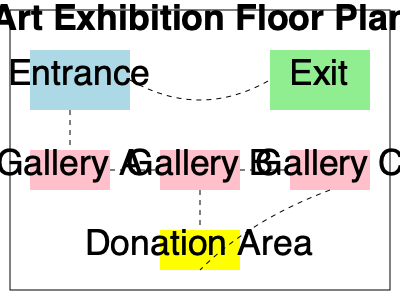Based on the floor plan of the art exhibition, what is the optimal guest flow path to maximize exposure to art galleries and encourage donations? List the areas in order. To determine the optimal guest flow path, we need to consider the following factors:

1. Ensure all visitors pass through each gallery.
2. End the path at the donation area to encourage contributions.
3. Create a logical flow that doesn't require backtracking.

Analyzing the floor plan:

1. Guests enter through the Entrance area.
2. Gallery A is closest to the entrance, making it the logical first stop.
3. Moving from Gallery A to Gallery B ensures a natural progression.
4. Gallery C is the next logical step after Gallery B.
5. The Donation Area is positioned centrally, making it an ideal final stop before exiting.
6. The Exit is conveniently located near Gallery C and the Donation Area.

Therefore, the optimal guest flow path is:

1. Entrance
2. Gallery A
3. Gallery B
4. Gallery C
5. Donation Area
6. Exit

This path ensures maximum exposure to all art galleries, encourages donations by placing the Donation Area at the end of the art viewing experience, and provides a smooth, logical flow through the exhibition space.
Answer: Entrance → Gallery A → Gallery B → Gallery C → Donation Area → Exit 